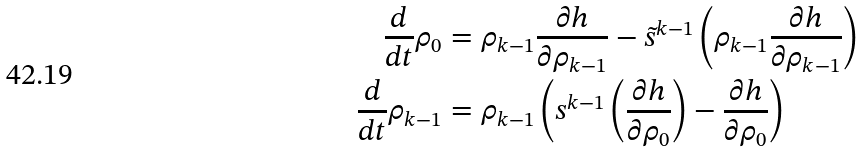<formula> <loc_0><loc_0><loc_500><loc_500>\frac { d } { d t } \rho _ { 0 } & = \rho _ { k - 1 } \frac { \partial h } { \partial \rho _ { k - 1 } } - \tilde { s } ^ { k - 1 } \left ( \rho _ { k - 1 } \frac { \partial h } { \partial \rho _ { k - 1 } } \right ) \\ \frac { d } { d t } \rho _ { k - 1 } & = \rho _ { k - 1 } \left ( s ^ { k - 1 } \left ( \frac { \partial h } { \partial \rho _ { 0 } } \right ) - \frac { \partial h } { \partial \rho _ { 0 } } \right )</formula> 